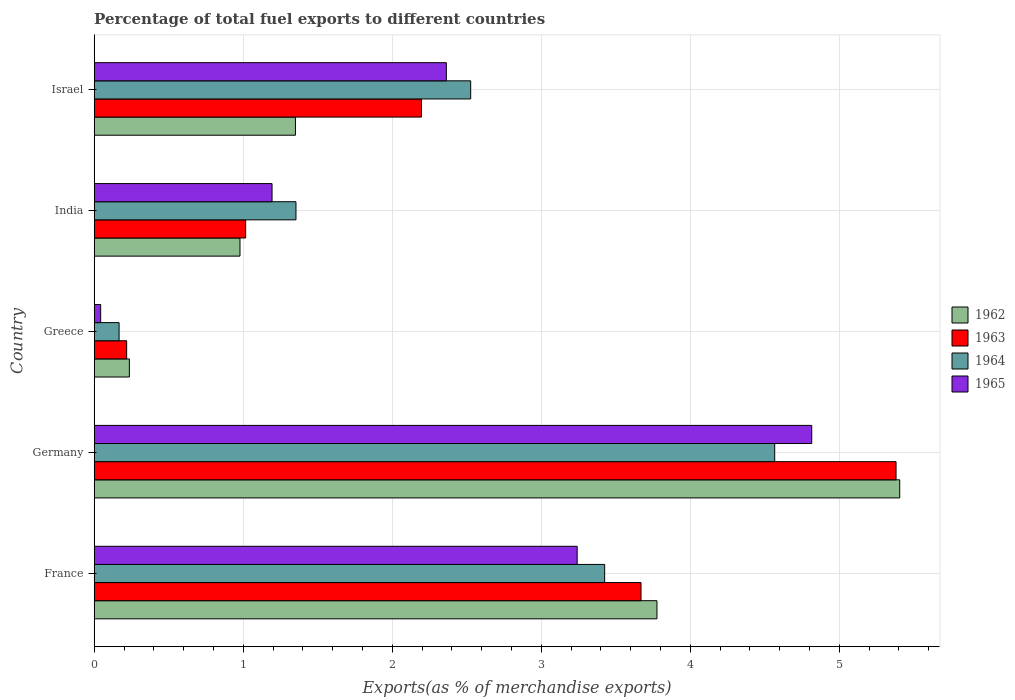How many groups of bars are there?
Provide a succinct answer. 5. Are the number of bars per tick equal to the number of legend labels?
Your response must be concise. Yes. How many bars are there on the 5th tick from the top?
Keep it short and to the point. 4. What is the label of the 4th group of bars from the top?
Your answer should be compact. Germany. In how many cases, is the number of bars for a given country not equal to the number of legend labels?
Offer a very short reply. 0. What is the percentage of exports to different countries in 1962 in Germany?
Your answer should be compact. 5.4. Across all countries, what is the maximum percentage of exports to different countries in 1962?
Make the answer very short. 5.4. Across all countries, what is the minimum percentage of exports to different countries in 1962?
Your answer should be compact. 0.24. What is the total percentage of exports to different countries in 1963 in the graph?
Offer a very short reply. 12.48. What is the difference between the percentage of exports to different countries in 1962 in France and that in Greece?
Your response must be concise. 3.54. What is the difference between the percentage of exports to different countries in 1965 in Greece and the percentage of exports to different countries in 1962 in Israel?
Your response must be concise. -1.31. What is the average percentage of exports to different countries in 1962 per country?
Provide a succinct answer. 2.35. What is the difference between the percentage of exports to different countries in 1963 and percentage of exports to different countries in 1962 in France?
Offer a very short reply. -0.11. What is the ratio of the percentage of exports to different countries in 1962 in Greece to that in India?
Your answer should be very brief. 0.24. Is the difference between the percentage of exports to different countries in 1963 in Greece and Israel greater than the difference between the percentage of exports to different countries in 1962 in Greece and Israel?
Your answer should be very brief. No. What is the difference between the highest and the second highest percentage of exports to different countries in 1965?
Give a very brief answer. 1.57. What is the difference between the highest and the lowest percentage of exports to different countries in 1962?
Give a very brief answer. 5.17. In how many countries, is the percentage of exports to different countries in 1963 greater than the average percentage of exports to different countries in 1963 taken over all countries?
Provide a succinct answer. 2. Is the sum of the percentage of exports to different countries in 1965 in France and Germany greater than the maximum percentage of exports to different countries in 1964 across all countries?
Your response must be concise. Yes. Is it the case that in every country, the sum of the percentage of exports to different countries in 1962 and percentage of exports to different countries in 1963 is greater than the sum of percentage of exports to different countries in 1965 and percentage of exports to different countries in 1964?
Keep it short and to the point. No. Are all the bars in the graph horizontal?
Your response must be concise. Yes. Does the graph contain any zero values?
Provide a succinct answer. No. Where does the legend appear in the graph?
Your answer should be very brief. Center right. How many legend labels are there?
Your answer should be very brief. 4. How are the legend labels stacked?
Offer a very short reply. Vertical. What is the title of the graph?
Give a very brief answer. Percentage of total fuel exports to different countries. Does "2001" appear as one of the legend labels in the graph?
Provide a short and direct response. No. What is the label or title of the X-axis?
Make the answer very short. Exports(as % of merchandise exports). What is the Exports(as % of merchandise exports) in 1962 in France?
Ensure brevity in your answer.  3.78. What is the Exports(as % of merchandise exports) in 1963 in France?
Provide a succinct answer. 3.67. What is the Exports(as % of merchandise exports) of 1964 in France?
Keep it short and to the point. 3.43. What is the Exports(as % of merchandise exports) of 1965 in France?
Your answer should be compact. 3.24. What is the Exports(as % of merchandise exports) of 1962 in Germany?
Your answer should be compact. 5.4. What is the Exports(as % of merchandise exports) in 1963 in Germany?
Your answer should be very brief. 5.38. What is the Exports(as % of merchandise exports) in 1964 in Germany?
Offer a very short reply. 4.57. What is the Exports(as % of merchandise exports) of 1965 in Germany?
Provide a short and direct response. 4.81. What is the Exports(as % of merchandise exports) in 1962 in Greece?
Keep it short and to the point. 0.24. What is the Exports(as % of merchandise exports) of 1963 in Greece?
Keep it short and to the point. 0.22. What is the Exports(as % of merchandise exports) in 1964 in Greece?
Offer a very short reply. 0.17. What is the Exports(as % of merchandise exports) of 1965 in Greece?
Keep it short and to the point. 0.04. What is the Exports(as % of merchandise exports) of 1962 in India?
Provide a short and direct response. 0.98. What is the Exports(as % of merchandise exports) in 1963 in India?
Your response must be concise. 1.02. What is the Exports(as % of merchandise exports) of 1964 in India?
Give a very brief answer. 1.35. What is the Exports(as % of merchandise exports) in 1965 in India?
Your answer should be very brief. 1.19. What is the Exports(as % of merchandise exports) in 1962 in Israel?
Give a very brief answer. 1.35. What is the Exports(as % of merchandise exports) of 1963 in Israel?
Make the answer very short. 2.2. What is the Exports(as % of merchandise exports) of 1964 in Israel?
Your answer should be very brief. 2.53. What is the Exports(as % of merchandise exports) of 1965 in Israel?
Make the answer very short. 2.36. Across all countries, what is the maximum Exports(as % of merchandise exports) in 1962?
Your answer should be very brief. 5.4. Across all countries, what is the maximum Exports(as % of merchandise exports) of 1963?
Your answer should be very brief. 5.38. Across all countries, what is the maximum Exports(as % of merchandise exports) of 1964?
Make the answer very short. 4.57. Across all countries, what is the maximum Exports(as % of merchandise exports) in 1965?
Provide a short and direct response. 4.81. Across all countries, what is the minimum Exports(as % of merchandise exports) in 1962?
Keep it short and to the point. 0.24. Across all countries, what is the minimum Exports(as % of merchandise exports) of 1963?
Offer a very short reply. 0.22. Across all countries, what is the minimum Exports(as % of merchandise exports) in 1964?
Provide a succinct answer. 0.17. Across all countries, what is the minimum Exports(as % of merchandise exports) in 1965?
Provide a succinct answer. 0.04. What is the total Exports(as % of merchandise exports) in 1962 in the graph?
Offer a terse response. 11.75. What is the total Exports(as % of merchandise exports) of 1963 in the graph?
Provide a succinct answer. 12.48. What is the total Exports(as % of merchandise exports) of 1964 in the graph?
Your answer should be compact. 12.04. What is the total Exports(as % of merchandise exports) in 1965 in the graph?
Provide a succinct answer. 11.66. What is the difference between the Exports(as % of merchandise exports) of 1962 in France and that in Germany?
Your answer should be compact. -1.63. What is the difference between the Exports(as % of merchandise exports) of 1963 in France and that in Germany?
Offer a terse response. -1.71. What is the difference between the Exports(as % of merchandise exports) of 1964 in France and that in Germany?
Keep it short and to the point. -1.14. What is the difference between the Exports(as % of merchandise exports) in 1965 in France and that in Germany?
Your answer should be very brief. -1.57. What is the difference between the Exports(as % of merchandise exports) in 1962 in France and that in Greece?
Your response must be concise. 3.54. What is the difference between the Exports(as % of merchandise exports) of 1963 in France and that in Greece?
Your answer should be compact. 3.45. What is the difference between the Exports(as % of merchandise exports) in 1964 in France and that in Greece?
Offer a very short reply. 3.26. What is the difference between the Exports(as % of merchandise exports) of 1965 in France and that in Greece?
Offer a terse response. 3.2. What is the difference between the Exports(as % of merchandise exports) of 1962 in France and that in India?
Offer a very short reply. 2.8. What is the difference between the Exports(as % of merchandise exports) of 1963 in France and that in India?
Provide a short and direct response. 2.65. What is the difference between the Exports(as % of merchandise exports) in 1964 in France and that in India?
Your answer should be compact. 2.07. What is the difference between the Exports(as % of merchandise exports) in 1965 in France and that in India?
Give a very brief answer. 2.05. What is the difference between the Exports(as % of merchandise exports) of 1962 in France and that in Israel?
Ensure brevity in your answer.  2.43. What is the difference between the Exports(as % of merchandise exports) in 1963 in France and that in Israel?
Provide a succinct answer. 1.47. What is the difference between the Exports(as % of merchandise exports) in 1964 in France and that in Israel?
Provide a short and direct response. 0.9. What is the difference between the Exports(as % of merchandise exports) in 1965 in France and that in Israel?
Offer a very short reply. 0.88. What is the difference between the Exports(as % of merchandise exports) of 1962 in Germany and that in Greece?
Your answer should be very brief. 5.17. What is the difference between the Exports(as % of merchandise exports) in 1963 in Germany and that in Greece?
Provide a short and direct response. 5.16. What is the difference between the Exports(as % of merchandise exports) in 1964 in Germany and that in Greece?
Make the answer very short. 4.4. What is the difference between the Exports(as % of merchandise exports) in 1965 in Germany and that in Greece?
Provide a short and direct response. 4.77. What is the difference between the Exports(as % of merchandise exports) of 1962 in Germany and that in India?
Give a very brief answer. 4.43. What is the difference between the Exports(as % of merchandise exports) in 1963 in Germany and that in India?
Your answer should be very brief. 4.36. What is the difference between the Exports(as % of merchandise exports) of 1964 in Germany and that in India?
Give a very brief answer. 3.21. What is the difference between the Exports(as % of merchandise exports) of 1965 in Germany and that in India?
Offer a very short reply. 3.62. What is the difference between the Exports(as % of merchandise exports) in 1962 in Germany and that in Israel?
Your answer should be compact. 4.05. What is the difference between the Exports(as % of merchandise exports) of 1963 in Germany and that in Israel?
Your answer should be compact. 3.18. What is the difference between the Exports(as % of merchandise exports) of 1964 in Germany and that in Israel?
Provide a succinct answer. 2.04. What is the difference between the Exports(as % of merchandise exports) of 1965 in Germany and that in Israel?
Give a very brief answer. 2.45. What is the difference between the Exports(as % of merchandise exports) of 1962 in Greece and that in India?
Give a very brief answer. -0.74. What is the difference between the Exports(as % of merchandise exports) in 1963 in Greece and that in India?
Offer a very short reply. -0.8. What is the difference between the Exports(as % of merchandise exports) in 1964 in Greece and that in India?
Keep it short and to the point. -1.19. What is the difference between the Exports(as % of merchandise exports) of 1965 in Greece and that in India?
Provide a short and direct response. -1.15. What is the difference between the Exports(as % of merchandise exports) in 1962 in Greece and that in Israel?
Provide a succinct answer. -1.11. What is the difference between the Exports(as % of merchandise exports) in 1963 in Greece and that in Israel?
Offer a terse response. -1.98. What is the difference between the Exports(as % of merchandise exports) of 1964 in Greece and that in Israel?
Provide a succinct answer. -2.36. What is the difference between the Exports(as % of merchandise exports) of 1965 in Greece and that in Israel?
Ensure brevity in your answer.  -2.32. What is the difference between the Exports(as % of merchandise exports) of 1962 in India and that in Israel?
Your answer should be very brief. -0.37. What is the difference between the Exports(as % of merchandise exports) of 1963 in India and that in Israel?
Your answer should be compact. -1.18. What is the difference between the Exports(as % of merchandise exports) of 1964 in India and that in Israel?
Make the answer very short. -1.17. What is the difference between the Exports(as % of merchandise exports) of 1965 in India and that in Israel?
Your answer should be compact. -1.17. What is the difference between the Exports(as % of merchandise exports) in 1962 in France and the Exports(as % of merchandise exports) in 1963 in Germany?
Your answer should be very brief. -1.6. What is the difference between the Exports(as % of merchandise exports) of 1962 in France and the Exports(as % of merchandise exports) of 1964 in Germany?
Your answer should be very brief. -0.79. What is the difference between the Exports(as % of merchandise exports) in 1962 in France and the Exports(as % of merchandise exports) in 1965 in Germany?
Offer a terse response. -1.04. What is the difference between the Exports(as % of merchandise exports) in 1963 in France and the Exports(as % of merchandise exports) in 1964 in Germany?
Keep it short and to the point. -0.9. What is the difference between the Exports(as % of merchandise exports) in 1963 in France and the Exports(as % of merchandise exports) in 1965 in Germany?
Your response must be concise. -1.15. What is the difference between the Exports(as % of merchandise exports) of 1964 in France and the Exports(as % of merchandise exports) of 1965 in Germany?
Provide a succinct answer. -1.39. What is the difference between the Exports(as % of merchandise exports) of 1962 in France and the Exports(as % of merchandise exports) of 1963 in Greece?
Keep it short and to the point. 3.56. What is the difference between the Exports(as % of merchandise exports) in 1962 in France and the Exports(as % of merchandise exports) in 1964 in Greece?
Make the answer very short. 3.61. What is the difference between the Exports(as % of merchandise exports) of 1962 in France and the Exports(as % of merchandise exports) of 1965 in Greece?
Ensure brevity in your answer.  3.73. What is the difference between the Exports(as % of merchandise exports) of 1963 in France and the Exports(as % of merchandise exports) of 1964 in Greece?
Make the answer very short. 3.5. What is the difference between the Exports(as % of merchandise exports) in 1963 in France and the Exports(as % of merchandise exports) in 1965 in Greece?
Keep it short and to the point. 3.63. What is the difference between the Exports(as % of merchandise exports) in 1964 in France and the Exports(as % of merchandise exports) in 1965 in Greece?
Ensure brevity in your answer.  3.38. What is the difference between the Exports(as % of merchandise exports) in 1962 in France and the Exports(as % of merchandise exports) in 1963 in India?
Offer a terse response. 2.76. What is the difference between the Exports(as % of merchandise exports) of 1962 in France and the Exports(as % of merchandise exports) of 1964 in India?
Your answer should be compact. 2.42. What is the difference between the Exports(as % of merchandise exports) of 1962 in France and the Exports(as % of merchandise exports) of 1965 in India?
Your answer should be compact. 2.58. What is the difference between the Exports(as % of merchandise exports) of 1963 in France and the Exports(as % of merchandise exports) of 1964 in India?
Provide a succinct answer. 2.32. What is the difference between the Exports(as % of merchandise exports) of 1963 in France and the Exports(as % of merchandise exports) of 1965 in India?
Keep it short and to the point. 2.48. What is the difference between the Exports(as % of merchandise exports) of 1964 in France and the Exports(as % of merchandise exports) of 1965 in India?
Your answer should be very brief. 2.23. What is the difference between the Exports(as % of merchandise exports) in 1962 in France and the Exports(as % of merchandise exports) in 1963 in Israel?
Offer a very short reply. 1.58. What is the difference between the Exports(as % of merchandise exports) of 1962 in France and the Exports(as % of merchandise exports) of 1964 in Israel?
Your answer should be compact. 1.25. What is the difference between the Exports(as % of merchandise exports) in 1962 in France and the Exports(as % of merchandise exports) in 1965 in Israel?
Provide a short and direct response. 1.41. What is the difference between the Exports(as % of merchandise exports) of 1963 in France and the Exports(as % of merchandise exports) of 1964 in Israel?
Your response must be concise. 1.14. What is the difference between the Exports(as % of merchandise exports) of 1963 in France and the Exports(as % of merchandise exports) of 1965 in Israel?
Your response must be concise. 1.31. What is the difference between the Exports(as % of merchandise exports) in 1964 in France and the Exports(as % of merchandise exports) in 1965 in Israel?
Your response must be concise. 1.06. What is the difference between the Exports(as % of merchandise exports) of 1962 in Germany and the Exports(as % of merchandise exports) of 1963 in Greece?
Your answer should be compact. 5.19. What is the difference between the Exports(as % of merchandise exports) of 1962 in Germany and the Exports(as % of merchandise exports) of 1964 in Greece?
Your answer should be very brief. 5.24. What is the difference between the Exports(as % of merchandise exports) in 1962 in Germany and the Exports(as % of merchandise exports) in 1965 in Greece?
Ensure brevity in your answer.  5.36. What is the difference between the Exports(as % of merchandise exports) in 1963 in Germany and the Exports(as % of merchandise exports) in 1964 in Greece?
Ensure brevity in your answer.  5.21. What is the difference between the Exports(as % of merchandise exports) of 1963 in Germany and the Exports(as % of merchandise exports) of 1965 in Greece?
Your response must be concise. 5.34. What is the difference between the Exports(as % of merchandise exports) in 1964 in Germany and the Exports(as % of merchandise exports) in 1965 in Greece?
Provide a short and direct response. 4.52. What is the difference between the Exports(as % of merchandise exports) in 1962 in Germany and the Exports(as % of merchandise exports) in 1963 in India?
Provide a short and direct response. 4.39. What is the difference between the Exports(as % of merchandise exports) in 1962 in Germany and the Exports(as % of merchandise exports) in 1964 in India?
Make the answer very short. 4.05. What is the difference between the Exports(as % of merchandise exports) in 1962 in Germany and the Exports(as % of merchandise exports) in 1965 in India?
Your response must be concise. 4.21. What is the difference between the Exports(as % of merchandise exports) in 1963 in Germany and the Exports(as % of merchandise exports) in 1964 in India?
Ensure brevity in your answer.  4.03. What is the difference between the Exports(as % of merchandise exports) in 1963 in Germany and the Exports(as % of merchandise exports) in 1965 in India?
Ensure brevity in your answer.  4.19. What is the difference between the Exports(as % of merchandise exports) in 1964 in Germany and the Exports(as % of merchandise exports) in 1965 in India?
Give a very brief answer. 3.37. What is the difference between the Exports(as % of merchandise exports) in 1962 in Germany and the Exports(as % of merchandise exports) in 1963 in Israel?
Your answer should be compact. 3.21. What is the difference between the Exports(as % of merchandise exports) of 1962 in Germany and the Exports(as % of merchandise exports) of 1964 in Israel?
Provide a succinct answer. 2.88. What is the difference between the Exports(as % of merchandise exports) of 1962 in Germany and the Exports(as % of merchandise exports) of 1965 in Israel?
Provide a succinct answer. 3.04. What is the difference between the Exports(as % of merchandise exports) of 1963 in Germany and the Exports(as % of merchandise exports) of 1964 in Israel?
Make the answer very short. 2.85. What is the difference between the Exports(as % of merchandise exports) of 1963 in Germany and the Exports(as % of merchandise exports) of 1965 in Israel?
Ensure brevity in your answer.  3.02. What is the difference between the Exports(as % of merchandise exports) in 1964 in Germany and the Exports(as % of merchandise exports) in 1965 in Israel?
Offer a terse response. 2.2. What is the difference between the Exports(as % of merchandise exports) of 1962 in Greece and the Exports(as % of merchandise exports) of 1963 in India?
Give a very brief answer. -0.78. What is the difference between the Exports(as % of merchandise exports) of 1962 in Greece and the Exports(as % of merchandise exports) of 1964 in India?
Offer a very short reply. -1.12. What is the difference between the Exports(as % of merchandise exports) in 1962 in Greece and the Exports(as % of merchandise exports) in 1965 in India?
Provide a short and direct response. -0.96. What is the difference between the Exports(as % of merchandise exports) in 1963 in Greece and the Exports(as % of merchandise exports) in 1964 in India?
Your answer should be compact. -1.14. What is the difference between the Exports(as % of merchandise exports) in 1963 in Greece and the Exports(as % of merchandise exports) in 1965 in India?
Your answer should be very brief. -0.98. What is the difference between the Exports(as % of merchandise exports) of 1964 in Greece and the Exports(as % of merchandise exports) of 1965 in India?
Your response must be concise. -1.03. What is the difference between the Exports(as % of merchandise exports) in 1962 in Greece and the Exports(as % of merchandise exports) in 1963 in Israel?
Ensure brevity in your answer.  -1.96. What is the difference between the Exports(as % of merchandise exports) of 1962 in Greece and the Exports(as % of merchandise exports) of 1964 in Israel?
Offer a terse response. -2.29. What is the difference between the Exports(as % of merchandise exports) of 1962 in Greece and the Exports(as % of merchandise exports) of 1965 in Israel?
Your response must be concise. -2.13. What is the difference between the Exports(as % of merchandise exports) of 1963 in Greece and the Exports(as % of merchandise exports) of 1964 in Israel?
Provide a short and direct response. -2.31. What is the difference between the Exports(as % of merchandise exports) of 1963 in Greece and the Exports(as % of merchandise exports) of 1965 in Israel?
Provide a short and direct response. -2.15. What is the difference between the Exports(as % of merchandise exports) of 1964 in Greece and the Exports(as % of merchandise exports) of 1965 in Israel?
Your answer should be compact. -2.2. What is the difference between the Exports(as % of merchandise exports) of 1962 in India and the Exports(as % of merchandise exports) of 1963 in Israel?
Your answer should be compact. -1.22. What is the difference between the Exports(as % of merchandise exports) in 1962 in India and the Exports(as % of merchandise exports) in 1964 in Israel?
Your answer should be very brief. -1.55. What is the difference between the Exports(as % of merchandise exports) in 1962 in India and the Exports(as % of merchandise exports) in 1965 in Israel?
Your answer should be compact. -1.38. What is the difference between the Exports(as % of merchandise exports) of 1963 in India and the Exports(as % of merchandise exports) of 1964 in Israel?
Your answer should be compact. -1.51. What is the difference between the Exports(as % of merchandise exports) in 1963 in India and the Exports(as % of merchandise exports) in 1965 in Israel?
Your answer should be compact. -1.35. What is the difference between the Exports(as % of merchandise exports) of 1964 in India and the Exports(as % of merchandise exports) of 1965 in Israel?
Give a very brief answer. -1.01. What is the average Exports(as % of merchandise exports) in 1962 per country?
Provide a short and direct response. 2.35. What is the average Exports(as % of merchandise exports) of 1963 per country?
Provide a short and direct response. 2.5. What is the average Exports(as % of merchandise exports) in 1964 per country?
Your answer should be compact. 2.41. What is the average Exports(as % of merchandise exports) of 1965 per country?
Offer a very short reply. 2.33. What is the difference between the Exports(as % of merchandise exports) in 1962 and Exports(as % of merchandise exports) in 1963 in France?
Offer a terse response. 0.11. What is the difference between the Exports(as % of merchandise exports) of 1962 and Exports(as % of merchandise exports) of 1964 in France?
Make the answer very short. 0.35. What is the difference between the Exports(as % of merchandise exports) in 1962 and Exports(as % of merchandise exports) in 1965 in France?
Ensure brevity in your answer.  0.54. What is the difference between the Exports(as % of merchandise exports) in 1963 and Exports(as % of merchandise exports) in 1964 in France?
Ensure brevity in your answer.  0.24. What is the difference between the Exports(as % of merchandise exports) in 1963 and Exports(as % of merchandise exports) in 1965 in France?
Your response must be concise. 0.43. What is the difference between the Exports(as % of merchandise exports) in 1964 and Exports(as % of merchandise exports) in 1965 in France?
Make the answer very short. 0.18. What is the difference between the Exports(as % of merchandise exports) in 1962 and Exports(as % of merchandise exports) in 1963 in Germany?
Ensure brevity in your answer.  0.02. What is the difference between the Exports(as % of merchandise exports) of 1962 and Exports(as % of merchandise exports) of 1964 in Germany?
Provide a short and direct response. 0.84. What is the difference between the Exports(as % of merchandise exports) in 1962 and Exports(as % of merchandise exports) in 1965 in Germany?
Offer a terse response. 0.59. What is the difference between the Exports(as % of merchandise exports) of 1963 and Exports(as % of merchandise exports) of 1964 in Germany?
Provide a succinct answer. 0.81. What is the difference between the Exports(as % of merchandise exports) in 1963 and Exports(as % of merchandise exports) in 1965 in Germany?
Give a very brief answer. 0.57. What is the difference between the Exports(as % of merchandise exports) of 1964 and Exports(as % of merchandise exports) of 1965 in Germany?
Keep it short and to the point. -0.25. What is the difference between the Exports(as % of merchandise exports) of 1962 and Exports(as % of merchandise exports) of 1963 in Greece?
Make the answer very short. 0.02. What is the difference between the Exports(as % of merchandise exports) of 1962 and Exports(as % of merchandise exports) of 1964 in Greece?
Your answer should be very brief. 0.07. What is the difference between the Exports(as % of merchandise exports) of 1962 and Exports(as % of merchandise exports) of 1965 in Greece?
Make the answer very short. 0.19. What is the difference between the Exports(as % of merchandise exports) in 1963 and Exports(as % of merchandise exports) in 1964 in Greece?
Ensure brevity in your answer.  0.05. What is the difference between the Exports(as % of merchandise exports) of 1963 and Exports(as % of merchandise exports) of 1965 in Greece?
Provide a succinct answer. 0.17. What is the difference between the Exports(as % of merchandise exports) of 1964 and Exports(as % of merchandise exports) of 1965 in Greece?
Offer a terse response. 0.12. What is the difference between the Exports(as % of merchandise exports) of 1962 and Exports(as % of merchandise exports) of 1963 in India?
Offer a terse response. -0.04. What is the difference between the Exports(as % of merchandise exports) in 1962 and Exports(as % of merchandise exports) in 1964 in India?
Give a very brief answer. -0.38. What is the difference between the Exports(as % of merchandise exports) in 1962 and Exports(as % of merchandise exports) in 1965 in India?
Your answer should be very brief. -0.22. What is the difference between the Exports(as % of merchandise exports) of 1963 and Exports(as % of merchandise exports) of 1964 in India?
Your response must be concise. -0.34. What is the difference between the Exports(as % of merchandise exports) of 1963 and Exports(as % of merchandise exports) of 1965 in India?
Offer a very short reply. -0.18. What is the difference between the Exports(as % of merchandise exports) of 1964 and Exports(as % of merchandise exports) of 1965 in India?
Your answer should be very brief. 0.16. What is the difference between the Exports(as % of merchandise exports) of 1962 and Exports(as % of merchandise exports) of 1963 in Israel?
Your response must be concise. -0.85. What is the difference between the Exports(as % of merchandise exports) in 1962 and Exports(as % of merchandise exports) in 1964 in Israel?
Ensure brevity in your answer.  -1.18. What is the difference between the Exports(as % of merchandise exports) of 1962 and Exports(as % of merchandise exports) of 1965 in Israel?
Keep it short and to the point. -1.01. What is the difference between the Exports(as % of merchandise exports) of 1963 and Exports(as % of merchandise exports) of 1964 in Israel?
Give a very brief answer. -0.33. What is the difference between the Exports(as % of merchandise exports) in 1963 and Exports(as % of merchandise exports) in 1965 in Israel?
Offer a very short reply. -0.17. What is the difference between the Exports(as % of merchandise exports) of 1964 and Exports(as % of merchandise exports) of 1965 in Israel?
Ensure brevity in your answer.  0.16. What is the ratio of the Exports(as % of merchandise exports) of 1962 in France to that in Germany?
Provide a short and direct response. 0.7. What is the ratio of the Exports(as % of merchandise exports) in 1963 in France to that in Germany?
Keep it short and to the point. 0.68. What is the ratio of the Exports(as % of merchandise exports) in 1964 in France to that in Germany?
Your answer should be compact. 0.75. What is the ratio of the Exports(as % of merchandise exports) in 1965 in France to that in Germany?
Provide a succinct answer. 0.67. What is the ratio of the Exports(as % of merchandise exports) in 1962 in France to that in Greece?
Keep it short and to the point. 16.01. What is the ratio of the Exports(as % of merchandise exports) of 1963 in France to that in Greece?
Give a very brief answer. 16.85. What is the ratio of the Exports(as % of merchandise exports) of 1964 in France to that in Greece?
Make the answer very short. 20.5. What is the ratio of the Exports(as % of merchandise exports) of 1965 in France to that in Greece?
Ensure brevity in your answer.  74.69. What is the ratio of the Exports(as % of merchandise exports) of 1962 in France to that in India?
Give a very brief answer. 3.86. What is the ratio of the Exports(as % of merchandise exports) of 1963 in France to that in India?
Your answer should be compact. 3.61. What is the ratio of the Exports(as % of merchandise exports) of 1964 in France to that in India?
Provide a succinct answer. 2.53. What is the ratio of the Exports(as % of merchandise exports) of 1965 in France to that in India?
Give a very brief answer. 2.72. What is the ratio of the Exports(as % of merchandise exports) of 1962 in France to that in Israel?
Ensure brevity in your answer.  2.8. What is the ratio of the Exports(as % of merchandise exports) of 1963 in France to that in Israel?
Give a very brief answer. 1.67. What is the ratio of the Exports(as % of merchandise exports) of 1964 in France to that in Israel?
Give a very brief answer. 1.36. What is the ratio of the Exports(as % of merchandise exports) of 1965 in France to that in Israel?
Keep it short and to the point. 1.37. What is the ratio of the Exports(as % of merchandise exports) of 1962 in Germany to that in Greece?
Offer a very short reply. 22.91. What is the ratio of the Exports(as % of merchandise exports) in 1963 in Germany to that in Greece?
Offer a terse response. 24.71. What is the ratio of the Exports(as % of merchandise exports) in 1964 in Germany to that in Greece?
Provide a succinct answer. 27.34. What is the ratio of the Exports(as % of merchandise exports) in 1965 in Germany to that in Greece?
Keep it short and to the point. 110.96. What is the ratio of the Exports(as % of merchandise exports) in 1962 in Germany to that in India?
Provide a succinct answer. 5.53. What is the ratio of the Exports(as % of merchandise exports) of 1963 in Germany to that in India?
Keep it short and to the point. 5.3. What is the ratio of the Exports(as % of merchandise exports) of 1964 in Germany to that in India?
Ensure brevity in your answer.  3.37. What is the ratio of the Exports(as % of merchandise exports) in 1965 in Germany to that in India?
Offer a very short reply. 4.03. What is the ratio of the Exports(as % of merchandise exports) of 1962 in Germany to that in Israel?
Offer a very short reply. 4. What is the ratio of the Exports(as % of merchandise exports) of 1963 in Germany to that in Israel?
Offer a very short reply. 2.45. What is the ratio of the Exports(as % of merchandise exports) of 1964 in Germany to that in Israel?
Make the answer very short. 1.81. What is the ratio of the Exports(as % of merchandise exports) in 1965 in Germany to that in Israel?
Provide a succinct answer. 2.04. What is the ratio of the Exports(as % of merchandise exports) in 1962 in Greece to that in India?
Your answer should be compact. 0.24. What is the ratio of the Exports(as % of merchandise exports) of 1963 in Greece to that in India?
Keep it short and to the point. 0.21. What is the ratio of the Exports(as % of merchandise exports) of 1964 in Greece to that in India?
Give a very brief answer. 0.12. What is the ratio of the Exports(as % of merchandise exports) in 1965 in Greece to that in India?
Give a very brief answer. 0.04. What is the ratio of the Exports(as % of merchandise exports) in 1962 in Greece to that in Israel?
Give a very brief answer. 0.17. What is the ratio of the Exports(as % of merchandise exports) of 1963 in Greece to that in Israel?
Give a very brief answer. 0.1. What is the ratio of the Exports(as % of merchandise exports) of 1964 in Greece to that in Israel?
Give a very brief answer. 0.07. What is the ratio of the Exports(as % of merchandise exports) in 1965 in Greece to that in Israel?
Keep it short and to the point. 0.02. What is the ratio of the Exports(as % of merchandise exports) of 1962 in India to that in Israel?
Give a very brief answer. 0.72. What is the ratio of the Exports(as % of merchandise exports) in 1963 in India to that in Israel?
Your answer should be compact. 0.46. What is the ratio of the Exports(as % of merchandise exports) of 1964 in India to that in Israel?
Your answer should be compact. 0.54. What is the ratio of the Exports(as % of merchandise exports) of 1965 in India to that in Israel?
Keep it short and to the point. 0.51. What is the difference between the highest and the second highest Exports(as % of merchandise exports) of 1962?
Your response must be concise. 1.63. What is the difference between the highest and the second highest Exports(as % of merchandise exports) in 1963?
Offer a very short reply. 1.71. What is the difference between the highest and the second highest Exports(as % of merchandise exports) in 1964?
Make the answer very short. 1.14. What is the difference between the highest and the second highest Exports(as % of merchandise exports) in 1965?
Ensure brevity in your answer.  1.57. What is the difference between the highest and the lowest Exports(as % of merchandise exports) in 1962?
Offer a very short reply. 5.17. What is the difference between the highest and the lowest Exports(as % of merchandise exports) in 1963?
Make the answer very short. 5.16. What is the difference between the highest and the lowest Exports(as % of merchandise exports) of 1964?
Your answer should be very brief. 4.4. What is the difference between the highest and the lowest Exports(as % of merchandise exports) in 1965?
Ensure brevity in your answer.  4.77. 